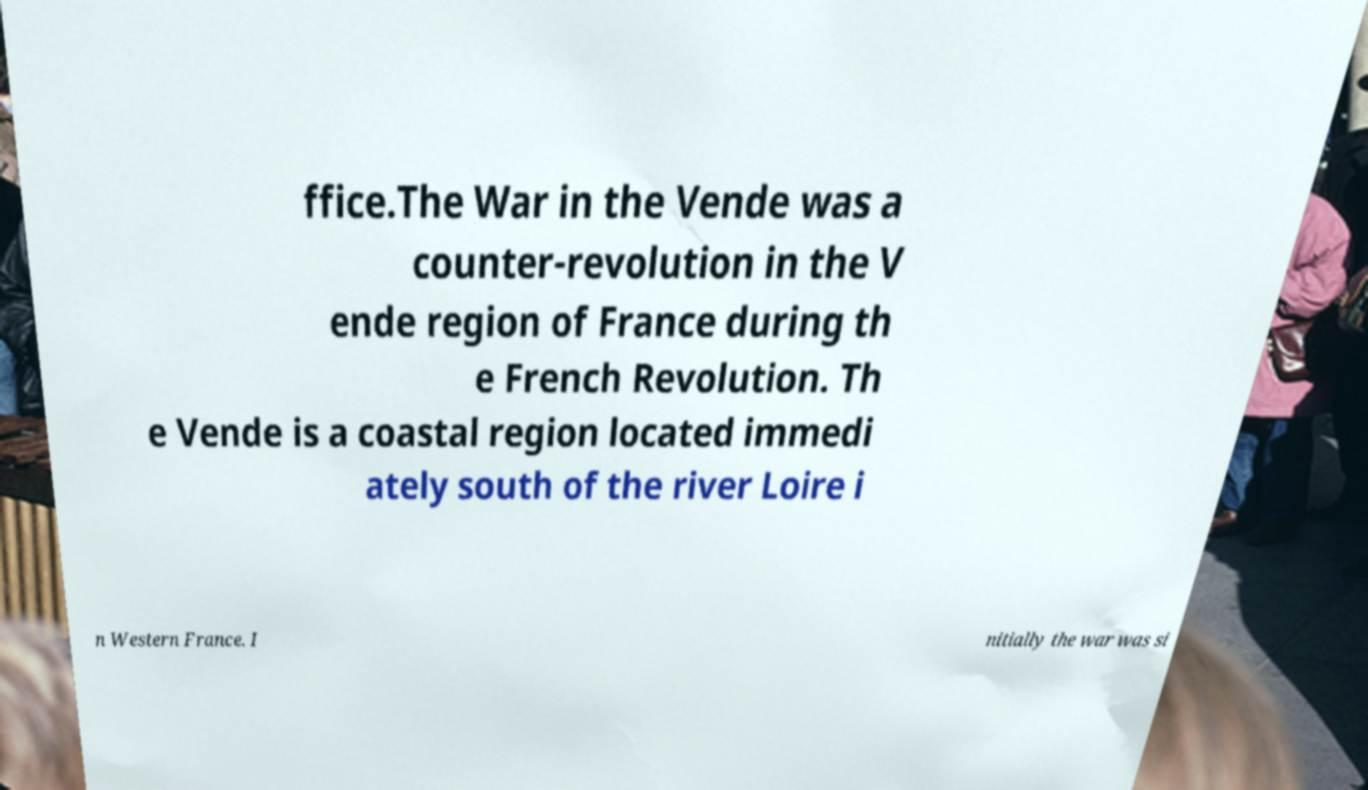Can you read and provide the text displayed in the image?This photo seems to have some interesting text. Can you extract and type it out for me? ffice.The War in the Vende was a counter-revolution in the V ende region of France during th e French Revolution. Th e Vende is a coastal region located immedi ately south of the river Loire i n Western France. I nitially the war was si 